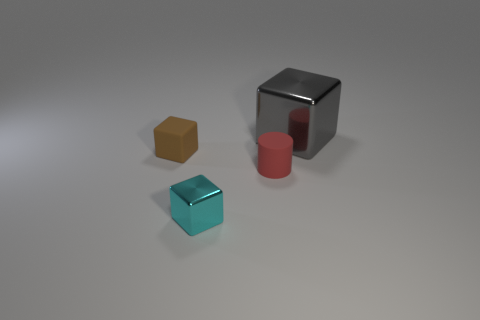Add 1 cyan shiny objects. How many objects exist? 5 Subtract all cylinders. How many objects are left? 3 Subtract all small cyan metallic things. Subtract all large gray shiny cubes. How many objects are left? 2 Add 4 red rubber cylinders. How many red rubber cylinders are left? 5 Add 2 blocks. How many blocks exist? 5 Subtract 0 yellow cubes. How many objects are left? 4 